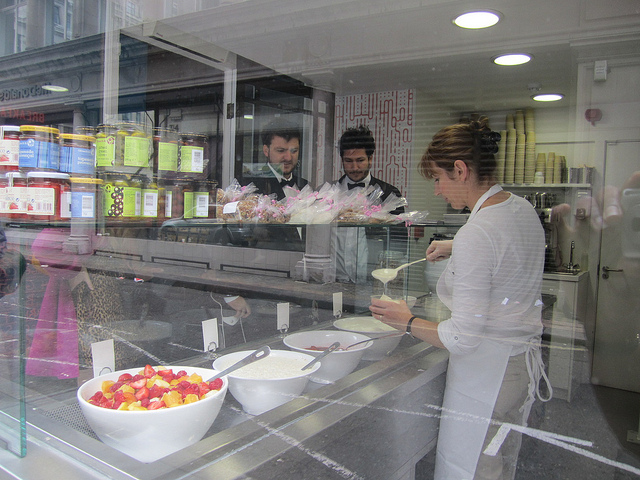How many people are there? There are three people visible in the image: One individual appears to be a customer standing in front of the glass display, and two appear to be employees or shopkeepers, positioned behind the counter inside the establishment. 